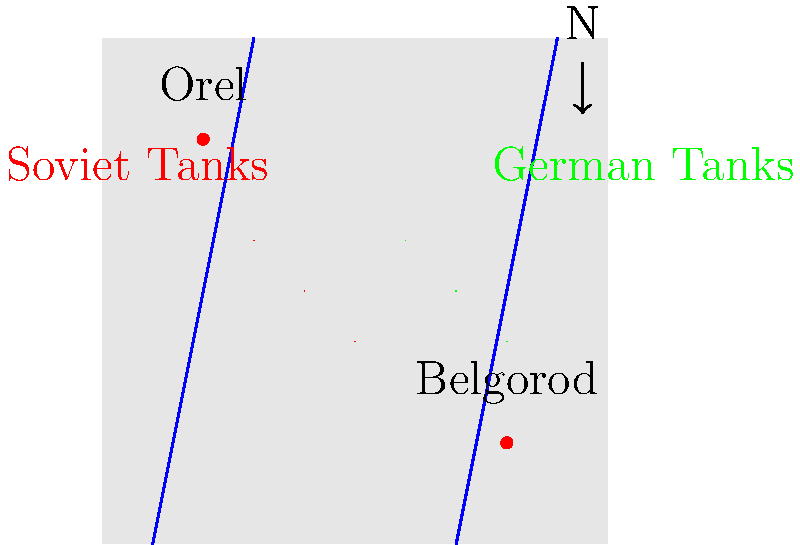Based on the tactical map of the Battle of Kursk, which strategic advantage did the Soviet tank formations have over the German forces? To answer this question, we need to analyze the positions of the Soviet and German tank formations on the map:

1. Location of forces:
   - Soviet tanks (red) are positioned in the northwest part of the map.
   - German tanks (green) are positioned in the southeast part of the map.

2. Terrain analysis:
   - Two rivers are shown on the map, running roughly north-south.
   - The Soviet tanks are positioned between these two rivers.

3. Strategic implications:
   - The rivers act as natural barriers, channeling the German advance.
   - The Soviet position between the rivers allows them to defend a narrower front.
   - This positioning enables the Soviets to concentrate their forces more effectively.

4. Historical context:
   - The Battle of Kursk was a defensive operation for the Soviets initially.
   - The Red Army had prepared extensive defensive positions in depth.

5. Tactical advantage:
   - The Soviet tank formations can more easily support each other due to their concentrated position.
   - The Germans would have to split their forces to attack on either side of the rivers or risk a bottleneck.

6. Operational flexibility:
   - The Soviet position allows for both defensive and counter-offensive operations.
   - They can quickly shift forces between sectors due to interior lines of communication.

Therefore, the key strategic advantage for the Soviet tank formations was their position between the two rivers, allowing for a stronger defensive posture and greater operational flexibility.
Answer: Interior lines of defense between rivers 